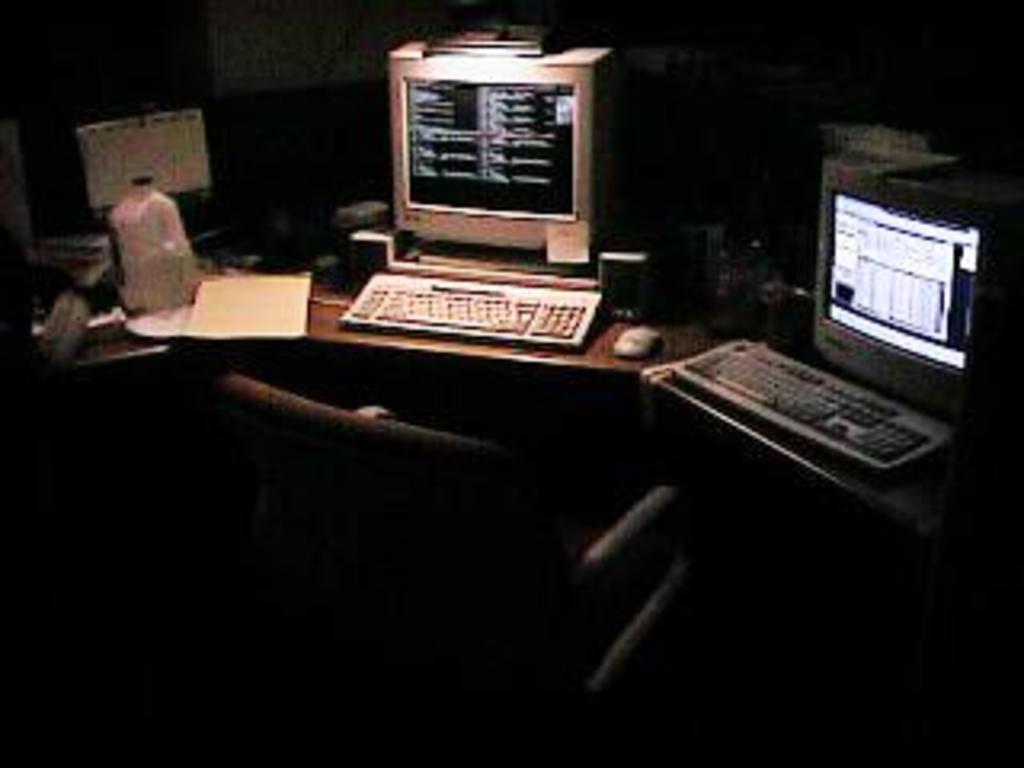How would you summarize this image in a sentence or two? This image is clicked in a room. In the front, there are two computers kept on a table along with keyboards and mouse. To the left, there is a bottle and books kept on the desk. In the background, there is a wall. At the bottom, there is a chair. 